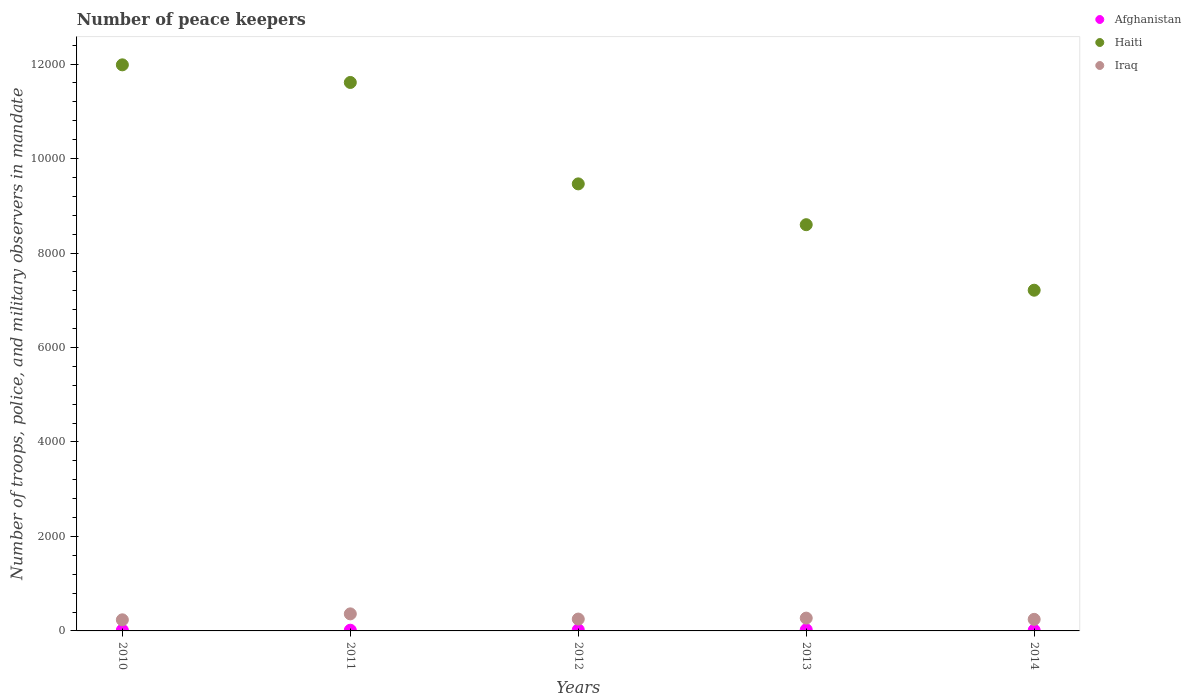How many different coloured dotlines are there?
Offer a terse response. 3. Is the number of dotlines equal to the number of legend labels?
Your answer should be very brief. Yes. Across all years, what is the maximum number of peace keepers in in Haiti?
Provide a short and direct response. 1.20e+04. Across all years, what is the minimum number of peace keepers in in Afghanistan?
Provide a short and direct response. 15. In which year was the number of peace keepers in in Iraq maximum?
Provide a short and direct response. 2011. In which year was the number of peace keepers in in Afghanistan minimum?
Keep it short and to the point. 2011. What is the total number of peace keepers in in Afghanistan in the graph?
Provide a short and direct response. 94. What is the difference between the number of peace keepers in in Haiti in 2011 and that in 2013?
Offer a terse response. 3011. What is the difference between the number of peace keepers in in Haiti in 2013 and the number of peace keepers in in Afghanistan in 2014?
Offer a terse response. 8585. What is the average number of peace keepers in in Iraq per year?
Provide a succinct answer. 272.6. In the year 2012, what is the difference between the number of peace keepers in in Iraq and number of peace keepers in in Haiti?
Your answer should be compact. -9213. In how many years, is the number of peace keepers in in Haiti greater than 400?
Your response must be concise. 5. What is the ratio of the number of peace keepers in in Haiti in 2013 to that in 2014?
Your response must be concise. 1.19. Is the difference between the number of peace keepers in in Iraq in 2011 and 2014 greater than the difference between the number of peace keepers in in Haiti in 2011 and 2014?
Give a very brief answer. No. What is the difference between the highest and the second highest number of peace keepers in in Afghanistan?
Make the answer very short. 2. What is the difference between the highest and the lowest number of peace keepers in in Haiti?
Provide a succinct answer. 4771. Is the sum of the number of peace keepers in in Haiti in 2012 and 2013 greater than the maximum number of peace keepers in in Iraq across all years?
Provide a succinct answer. Yes. Is it the case that in every year, the sum of the number of peace keepers in in Afghanistan and number of peace keepers in in Iraq  is greater than the number of peace keepers in in Haiti?
Keep it short and to the point. No. Is the number of peace keepers in in Haiti strictly greater than the number of peace keepers in in Afghanistan over the years?
Offer a terse response. Yes. Is the number of peace keepers in in Iraq strictly less than the number of peace keepers in in Afghanistan over the years?
Your answer should be compact. No. Does the graph contain any zero values?
Keep it short and to the point. No. Where does the legend appear in the graph?
Your answer should be very brief. Top right. How many legend labels are there?
Make the answer very short. 3. What is the title of the graph?
Offer a terse response. Number of peace keepers. Does "Mozambique" appear as one of the legend labels in the graph?
Provide a succinct answer. No. What is the label or title of the X-axis?
Provide a short and direct response. Years. What is the label or title of the Y-axis?
Your answer should be compact. Number of troops, police, and military observers in mandate. What is the Number of troops, police, and military observers in mandate of Haiti in 2010?
Keep it short and to the point. 1.20e+04. What is the Number of troops, police, and military observers in mandate in Iraq in 2010?
Ensure brevity in your answer.  235. What is the Number of troops, police, and military observers in mandate of Haiti in 2011?
Keep it short and to the point. 1.16e+04. What is the Number of troops, police, and military observers in mandate in Iraq in 2011?
Your answer should be compact. 361. What is the Number of troops, police, and military observers in mandate of Afghanistan in 2012?
Offer a terse response. 23. What is the Number of troops, police, and military observers in mandate of Haiti in 2012?
Offer a very short reply. 9464. What is the Number of troops, police, and military observers in mandate of Iraq in 2012?
Make the answer very short. 251. What is the Number of troops, police, and military observers in mandate of Afghanistan in 2013?
Offer a very short reply. 25. What is the Number of troops, police, and military observers in mandate of Haiti in 2013?
Offer a very short reply. 8600. What is the Number of troops, police, and military observers in mandate in Iraq in 2013?
Provide a succinct answer. 271. What is the Number of troops, police, and military observers in mandate of Afghanistan in 2014?
Ensure brevity in your answer.  15. What is the Number of troops, police, and military observers in mandate of Haiti in 2014?
Your answer should be very brief. 7213. What is the Number of troops, police, and military observers in mandate of Iraq in 2014?
Offer a terse response. 245. Across all years, what is the maximum Number of troops, police, and military observers in mandate of Haiti?
Provide a short and direct response. 1.20e+04. Across all years, what is the maximum Number of troops, police, and military observers in mandate of Iraq?
Provide a short and direct response. 361. Across all years, what is the minimum Number of troops, police, and military observers in mandate of Haiti?
Your response must be concise. 7213. Across all years, what is the minimum Number of troops, police, and military observers in mandate of Iraq?
Offer a terse response. 235. What is the total Number of troops, police, and military observers in mandate of Afghanistan in the graph?
Offer a terse response. 94. What is the total Number of troops, police, and military observers in mandate in Haiti in the graph?
Make the answer very short. 4.89e+04. What is the total Number of troops, police, and military observers in mandate of Iraq in the graph?
Your answer should be compact. 1363. What is the difference between the Number of troops, police, and military observers in mandate in Haiti in 2010 and that in 2011?
Keep it short and to the point. 373. What is the difference between the Number of troops, police, and military observers in mandate of Iraq in 2010 and that in 2011?
Ensure brevity in your answer.  -126. What is the difference between the Number of troops, police, and military observers in mandate of Afghanistan in 2010 and that in 2012?
Ensure brevity in your answer.  -7. What is the difference between the Number of troops, police, and military observers in mandate in Haiti in 2010 and that in 2012?
Provide a short and direct response. 2520. What is the difference between the Number of troops, police, and military observers in mandate of Afghanistan in 2010 and that in 2013?
Make the answer very short. -9. What is the difference between the Number of troops, police, and military observers in mandate of Haiti in 2010 and that in 2013?
Your answer should be very brief. 3384. What is the difference between the Number of troops, police, and military observers in mandate in Iraq in 2010 and that in 2013?
Ensure brevity in your answer.  -36. What is the difference between the Number of troops, police, and military observers in mandate of Afghanistan in 2010 and that in 2014?
Offer a terse response. 1. What is the difference between the Number of troops, police, and military observers in mandate of Haiti in 2010 and that in 2014?
Make the answer very short. 4771. What is the difference between the Number of troops, police, and military observers in mandate in Afghanistan in 2011 and that in 2012?
Make the answer very short. -8. What is the difference between the Number of troops, police, and military observers in mandate of Haiti in 2011 and that in 2012?
Your answer should be compact. 2147. What is the difference between the Number of troops, police, and military observers in mandate in Iraq in 2011 and that in 2012?
Your answer should be very brief. 110. What is the difference between the Number of troops, police, and military observers in mandate of Haiti in 2011 and that in 2013?
Offer a very short reply. 3011. What is the difference between the Number of troops, police, and military observers in mandate of Iraq in 2011 and that in 2013?
Make the answer very short. 90. What is the difference between the Number of troops, police, and military observers in mandate of Haiti in 2011 and that in 2014?
Make the answer very short. 4398. What is the difference between the Number of troops, police, and military observers in mandate in Iraq in 2011 and that in 2014?
Keep it short and to the point. 116. What is the difference between the Number of troops, police, and military observers in mandate in Haiti in 2012 and that in 2013?
Provide a succinct answer. 864. What is the difference between the Number of troops, police, and military observers in mandate of Iraq in 2012 and that in 2013?
Provide a short and direct response. -20. What is the difference between the Number of troops, police, and military observers in mandate in Afghanistan in 2012 and that in 2014?
Ensure brevity in your answer.  8. What is the difference between the Number of troops, police, and military observers in mandate in Haiti in 2012 and that in 2014?
Provide a succinct answer. 2251. What is the difference between the Number of troops, police, and military observers in mandate of Afghanistan in 2013 and that in 2014?
Keep it short and to the point. 10. What is the difference between the Number of troops, police, and military observers in mandate of Haiti in 2013 and that in 2014?
Provide a succinct answer. 1387. What is the difference between the Number of troops, police, and military observers in mandate of Afghanistan in 2010 and the Number of troops, police, and military observers in mandate of Haiti in 2011?
Your response must be concise. -1.16e+04. What is the difference between the Number of troops, police, and military observers in mandate of Afghanistan in 2010 and the Number of troops, police, and military observers in mandate of Iraq in 2011?
Offer a very short reply. -345. What is the difference between the Number of troops, police, and military observers in mandate of Haiti in 2010 and the Number of troops, police, and military observers in mandate of Iraq in 2011?
Your answer should be compact. 1.16e+04. What is the difference between the Number of troops, police, and military observers in mandate in Afghanistan in 2010 and the Number of troops, police, and military observers in mandate in Haiti in 2012?
Your answer should be very brief. -9448. What is the difference between the Number of troops, police, and military observers in mandate of Afghanistan in 2010 and the Number of troops, police, and military observers in mandate of Iraq in 2012?
Provide a succinct answer. -235. What is the difference between the Number of troops, police, and military observers in mandate of Haiti in 2010 and the Number of troops, police, and military observers in mandate of Iraq in 2012?
Keep it short and to the point. 1.17e+04. What is the difference between the Number of troops, police, and military observers in mandate in Afghanistan in 2010 and the Number of troops, police, and military observers in mandate in Haiti in 2013?
Provide a short and direct response. -8584. What is the difference between the Number of troops, police, and military observers in mandate in Afghanistan in 2010 and the Number of troops, police, and military observers in mandate in Iraq in 2013?
Make the answer very short. -255. What is the difference between the Number of troops, police, and military observers in mandate in Haiti in 2010 and the Number of troops, police, and military observers in mandate in Iraq in 2013?
Provide a short and direct response. 1.17e+04. What is the difference between the Number of troops, police, and military observers in mandate in Afghanistan in 2010 and the Number of troops, police, and military observers in mandate in Haiti in 2014?
Ensure brevity in your answer.  -7197. What is the difference between the Number of troops, police, and military observers in mandate of Afghanistan in 2010 and the Number of troops, police, and military observers in mandate of Iraq in 2014?
Your answer should be compact. -229. What is the difference between the Number of troops, police, and military observers in mandate of Haiti in 2010 and the Number of troops, police, and military observers in mandate of Iraq in 2014?
Provide a short and direct response. 1.17e+04. What is the difference between the Number of troops, police, and military observers in mandate in Afghanistan in 2011 and the Number of troops, police, and military observers in mandate in Haiti in 2012?
Provide a succinct answer. -9449. What is the difference between the Number of troops, police, and military observers in mandate in Afghanistan in 2011 and the Number of troops, police, and military observers in mandate in Iraq in 2012?
Your answer should be very brief. -236. What is the difference between the Number of troops, police, and military observers in mandate of Haiti in 2011 and the Number of troops, police, and military observers in mandate of Iraq in 2012?
Your answer should be compact. 1.14e+04. What is the difference between the Number of troops, police, and military observers in mandate of Afghanistan in 2011 and the Number of troops, police, and military observers in mandate of Haiti in 2013?
Give a very brief answer. -8585. What is the difference between the Number of troops, police, and military observers in mandate in Afghanistan in 2011 and the Number of troops, police, and military observers in mandate in Iraq in 2013?
Provide a short and direct response. -256. What is the difference between the Number of troops, police, and military observers in mandate in Haiti in 2011 and the Number of troops, police, and military observers in mandate in Iraq in 2013?
Ensure brevity in your answer.  1.13e+04. What is the difference between the Number of troops, police, and military observers in mandate in Afghanistan in 2011 and the Number of troops, police, and military observers in mandate in Haiti in 2014?
Keep it short and to the point. -7198. What is the difference between the Number of troops, police, and military observers in mandate of Afghanistan in 2011 and the Number of troops, police, and military observers in mandate of Iraq in 2014?
Offer a terse response. -230. What is the difference between the Number of troops, police, and military observers in mandate of Haiti in 2011 and the Number of troops, police, and military observers in mandate of Iraq in 2014?
Your response must be concise. 1.14e+04. What is the difference between the Number of troops, police, and military observers in mandate of Afghanistan in 2012 and the Number of troops, police, and military observers in mandate of Haiti in 2013?
Your answer should be compact. -8577. What is the difference between the Number of troops, police, and military observers in mandate of Afghanistan in 2012 and the Number of troops, police, and military observers in mandate of Iraq in 2013?
Give a very brief answer. -248. What is the difference between the Number of troops, police, and military observers in mandate in Haiti in 2012 and the Number of troops, police, and military observers in mandate in Iraq in 2013?
Your answer should be very brief. 9193. What is the difference between the Number of troops, police, and military observers in mandate of Afghanistan in 2012 and the Number of troops, police, and military observers in mandate of Haiti in 2014?
Provide a short and direct response. -7190. What is the difference between the Number of troops, police, and military observers in mandate in Afghanistan in 2012 and the Number of troops, police, and military observers in mandate in Iraq in 2014?
Make the answer very short. -222. What is the difference between the Number of troops, police, and military observers in mandate of Haiti in 2012 and the Number of troops, police, and military observers in mandate of Iraq in 2014?
Your response must be concise. 9219. What is the difference between the Number of troops, police, and military observers in mandate in Afghanistan in 2013 and the Number of troops, police, and military observers in mandate in Haiti in 2014?
Give a very brief answer. -7188. What is the difference between the Number of troops, police, and military observers in mandate in Afghanistan in 2013 and the Number of troops, police, and military observers in mandate in Iraq in 2014?
Offer a terse response. -220. What is the difference between the Number of troops, police, and military observers in mandate in Haiti in 2013 and the Number of troops, police, and military observers in mandate in Iraq in 2014?
Keep it short and to the point. 8355. What is the average Number of troops, police, and military observers in mandate of Afghanistan per year?
Offer a terse response. 18.8. What is the average Number of troops, police, and military observers in mandate of Haiti per year?
Ensure brevity in your answer.  9774.4. What is the average Number of troops, police, and military observers in mandate in Iraq per year?
Your response must be concise. 272.6. In the year 2010, what is the difference between the Number of troops, police, and military observers in mandate in Afghanistan and Number of troops, police, and military observers in mandate in Haiti?
Provide a succinct answer. -1.20e+04. In the year 2010, what is the difference between the Number of troops, police, and military observers in mandate of Afghanistan and Number of troops, police, and military observers in mandate of Iraq?
Your response must be concise. -219. In the year 2010, what is the difference between the Number of troops, police, and military observers in mandate in Haiti and Number of troops, police, and military observers in mandate in Iraq?
Provide a succinct answer. 1.17e+04. In the year 2011, what is the difference between the Number of troops, police, and military observers in mandate in Afghanistan and Number of troops, police, and military observers in mandate in Haiti?
Your answer should be very brief. -1.16e+04. In the year 2011, what is the difference between the Number of troops, police, and military observers in mandate in Afghanistan and Number of troops, police, and military observers in mandate in Iraq?
Give a very brief answer. -346. In the year 2011, what is the difference between the Number of troops, police, and military observers in mandate of Haiti and Number of troops, police, and military observers in mandate of Iraq?
Your answer should be compact. 1.12e+04. In the year 2012, what is the difference between the Number of troops, police, and military observers in mandate in Afghanistan and Number of troops, police, and military observers in mandate in Haiti?
Offer a very short reply. -9441. In the year 2012, what is the difference between the Number of troops, police, and military observers in mandate in Afghanistan and Number of troops, police, and military observers in mandate in Iraq?
Keep it short and to the point. -228. In the year 2012, what is the difference between the Number of troops, police, and military observers in mandate of Haiti and Number of troops, police, and military observers in mandate of Iraq?
Provide a short and direct response. 9213. In the year 2013, what is the difference between the Number of troops, police, and military observers in mandate of Afghanistan and Number of troops, police, and military observers in mandate of Haiti?
Your answer should be very brief. -8575. In the year 2013, what is the difference between the Number of troops, police, and military observers in mandate in Afghanistan and Number of troops, police, and military observers in mandate in Iraq?
Provide a short and direct response. -246. In the year 2013, what is the difference between the Number of troops, police, and military observers in mandate in Haiti and Number of troops, police, and military observers in mandate in Iraq?
Your answer should be compact. 8329. In the year 2014, what is the difference between the Number of troops, police, and military observers in mandate of Afghanistan and Number of troops, police, and military observers in mandate of Haiti?
Offer a very short reply. -7198. In the year 2014, what is the difference between the Number of troops, police, and military observers in mandate in Afghanistan and Number of troops, police, and military observers in mandate in Iraq?
Offer a terse response. -230. In the year 2014, what is the difference between the Number of troops, police, and military observers in mandate of Haiti and Number of troops, police, and military observers in mandate of Iraq?
Offer a terse response. 6968. What is the ratio of the Number of troops, police, and military observers in mandate in Afghanistan in 2010 to that in 2011?
Provide a short and direct response. 1.07. What is the ratio of the Number of troops, police, and military observers in mandate of Haiti in 2010 to that in 2011?
Make the answer very short. 1.03. What is the ratio of the Number of troops, police, and military observers in mandate in Iraq in 2010 to that in 2011?
Provide a short and direct response. 0.65. What is the ratio of the Number of troops, police, and military observers in mandate in Afghanistan in 2010 to that in 2012?
Your response must be concise. 0.7. What is the ratio of the Number of troops, police, and military observers in mandate of Haiti in 2010 to that in 2012?
Your response must be concise. 1.27. What is the ratio of the Number of troops, police, and military observers in mandate of Iraq in 2010 to that in 2012?
Your answer should be very brief. 0.94. What is the ratio of the Number of troops, police, and military observers in mandate in Afghanistan in 2010 to that in 2013?
Provide a succinct answer. 0.64. What is the ratio of the Number of troops, police, and military observers in mandate in Haiti in 2010 to that in 2013?
Provide a succinct answer. 1.39. What is the ratio of the Number of troops, police, and military observers in mandate of Iraq in 2010 to that in 2013?
Provide a short and direct response. 0.87. What is the ratio of the Number of troops, police, and military observers in mandate of Afghanistan in 2010 to that in 2014?
Give a very brief answer. 1.07. What is the ratio of the Number of troops, police, and military observers in mandate of Haiti in 2010 to that in 2014?
Your answer should be very brief. 1.66. What is the ratio of the Number of troops, police, and military observers in mandate of Iraq in 2010 to that in 2014?
Offer a very short reply. 0.96. What is the ratio of the Number of troops, police, and military observers in mandate in Afghanistan in 2011 to that in 2012?
Provide a succinct answer. 0.65. What is the ratio of the Number of troops, police, and military observers in mandate in Haiti in 2011 to that in 2012?
Make the answer very short. 1.23. What is the ratio of the Number of troops, police, and military observers in mandate in Iraq in 2011 to that in 2012?
Make the answer very short. 1.44. What is the ratio of the Number of troops, police, and military observers in mandate of Haiti in 2011 to that in 2013?
Give a very brief answer. 1.35. What is the ratio of the Number of troops, police, and military observers in mandate of Iraq in 2011 to that in 2013?
Provide a short and direct response. 1.33. What is the ratio of the Number of troops, police, and military observers in mandate of Afghanistan in 2011 to that in 2014?
Your answer should be very brief. 1. What is the ratio of the Number of troops, police, and military observers in mandate in Haiti in 2011 to that in 2014?
Ensure brevity in your answer.  1.61. What is the ratio of the Number of troops, police, and military observers in mandate in Iraq in 2011 to that in 2014?
Offer a very short reply. 1.47. What is the ratio of the Number of troops, police, and military observers in mandate in Haiti in 2012 to that in 2013?
Your answer should be compact. 1.1. What is the ratio of the Number of troops, police, and military observers in mandate of Iraq in 2012 to that in 2013?
Your response must be concise. 0.93. What is the ratio of the Number of troops, police, and military observers in mandate of Afghanistan in 2012 to that in 2014?
Your answer should be compact. 1.53. What is the ratio of the Number of troops, police, and military observers in mandate in Haiti in 2012 to that in 2014?
Make the answer very short. 1.31. What is the ratio of the Number of troops, police, and military observers in mandate of Iraq in 2012 to that in 2014?
Your answer should be compact. 1.02. What is the ratio of the Number of troops, police, and military observers in mandate in Haiti in 2013 to that in 2014?
Offer a terse response. 1.19. What is the ratio of the Number of troops, police, and military observers in mandate of Iraq in 2013 to that in 2014?
Your response must be concise. 1.11. What is the difference between the highest and the second highest Number of troops, police, and military observers in mandate in Afghanistan?
Ensure brevity in your answer.  2. What is the difference between the highest and the second highest Number of troops, police, and military observers in mandate in Haiti?
Ensure brevity in your answer.  373. What is the difference between the highest and the second highest Number of troops, police, and military observers in mandate in Iraq?
Your answer should be very brief. 90. What is the difference between the highest and the lowest Number of troops, police, and military observers in mandate of Afghanistan?
Your answer should be very brief. 10. What is the difference between the highest and the lowest Number of troops, police, and military observers in mandate of Haiti?
Your response must be concise. 4771. What is the difference between the highest and the lowest Number of troops, police, and military observers in mandate of Iraq?
Offer a very short reply. 126. 